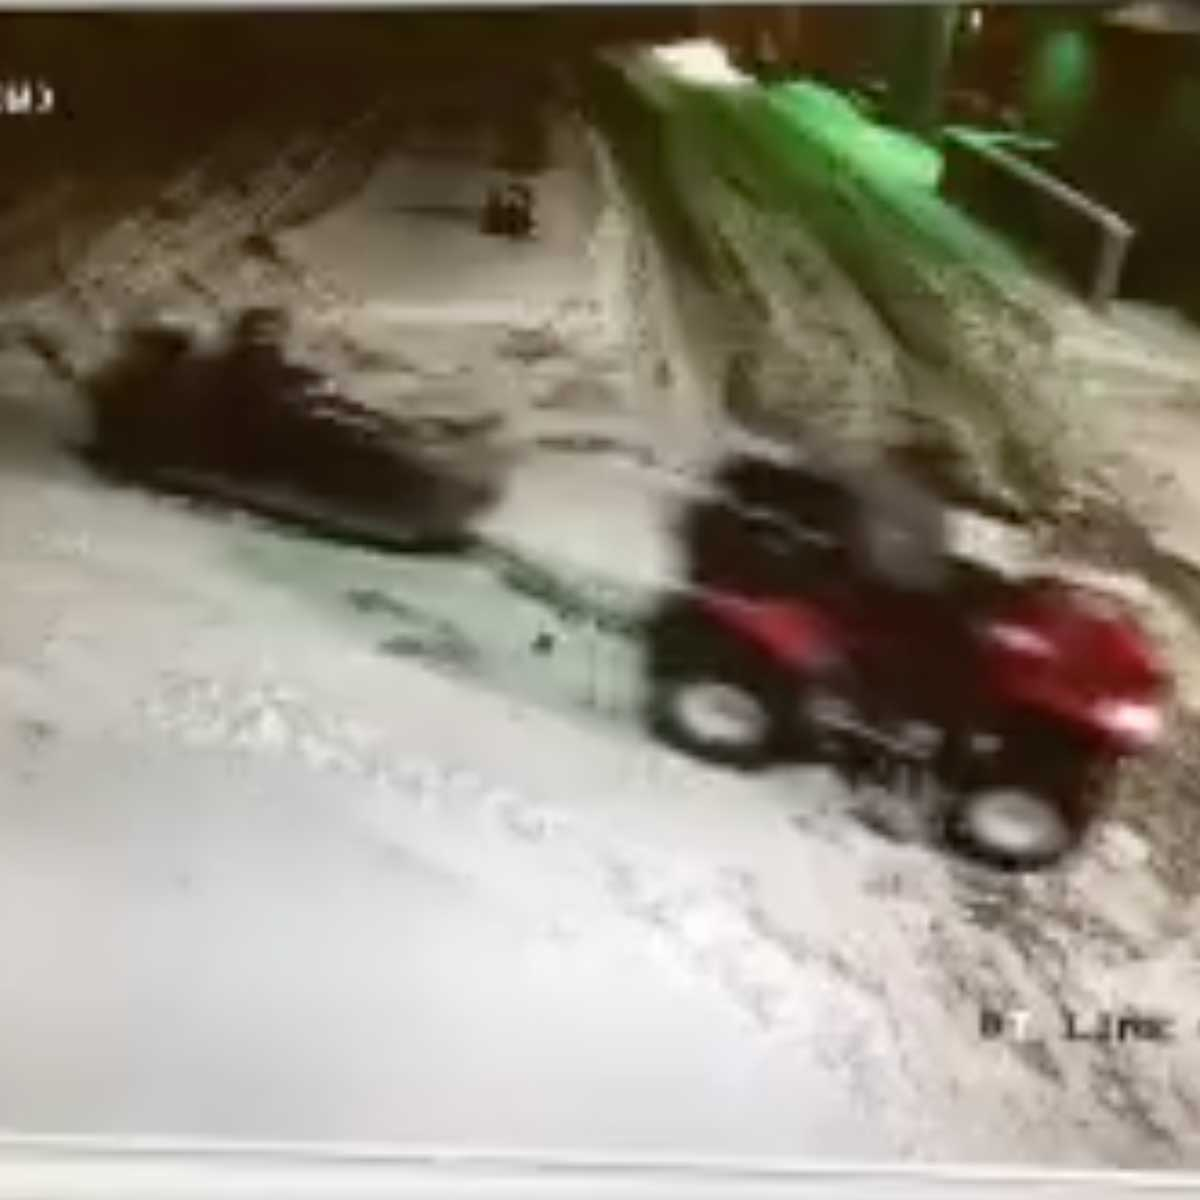If you were to create a backstory for why this scene is happening, what would it be? Imagine a remote, snowy outpost where a group of explorers are stationed. The ATV rider is one of the explorers returning to the base after a day of checking remote sensors and equipment. The smaller object in the distance is another ATV that stopped due to a minor malfunction. The explorer in the active ATV is heading to assist their colleague, ensuring that everyone gets back to the base safely before nightfall brings even harsher conditions. This cooperation and teamwork are essential in such an isolated, hostile environment. 